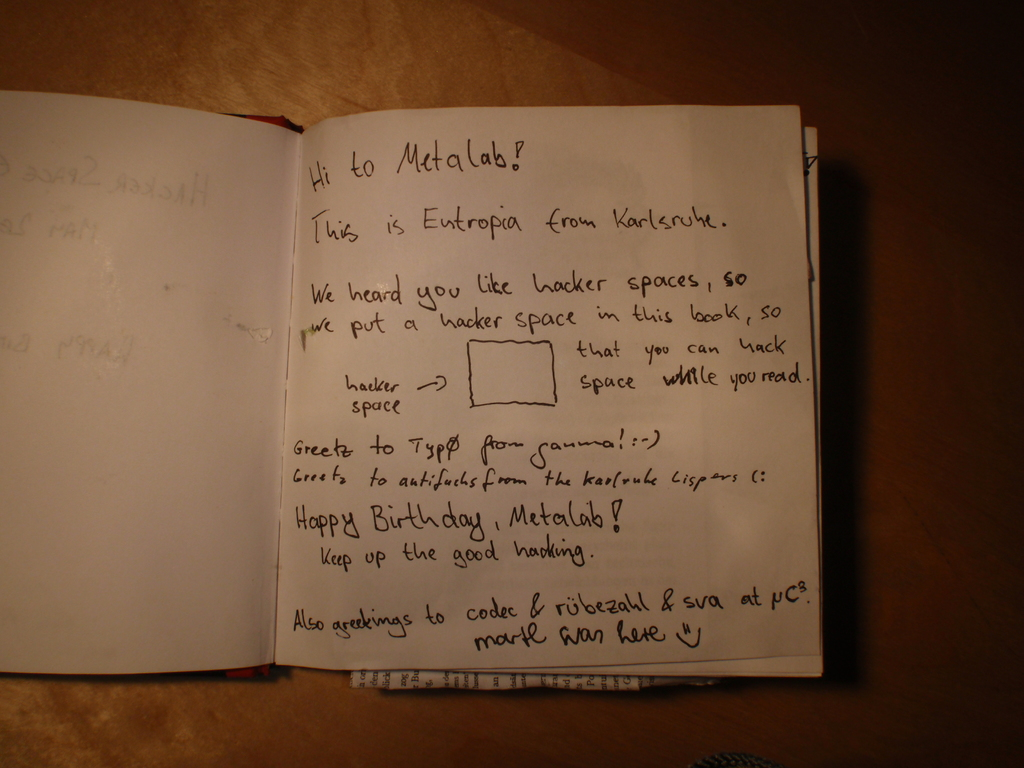Can you explain the significance of hacker spaces mentioned in this note? Hacker spaces, as mentioned in the note, are community-operated workspaces where people with common interests, often in computers, technology, science, digital art, and electronic art, can meet, socialize and collaborate. The note reflects a deep appreciation for such environments, suggesting that they foster creativity and innovation. By integrating a hacker space 'in this book', Entropia playfully adapts this concept into a personal, unique gift for Metalab, symbolizing their shared passion for creative and technological exploration. 